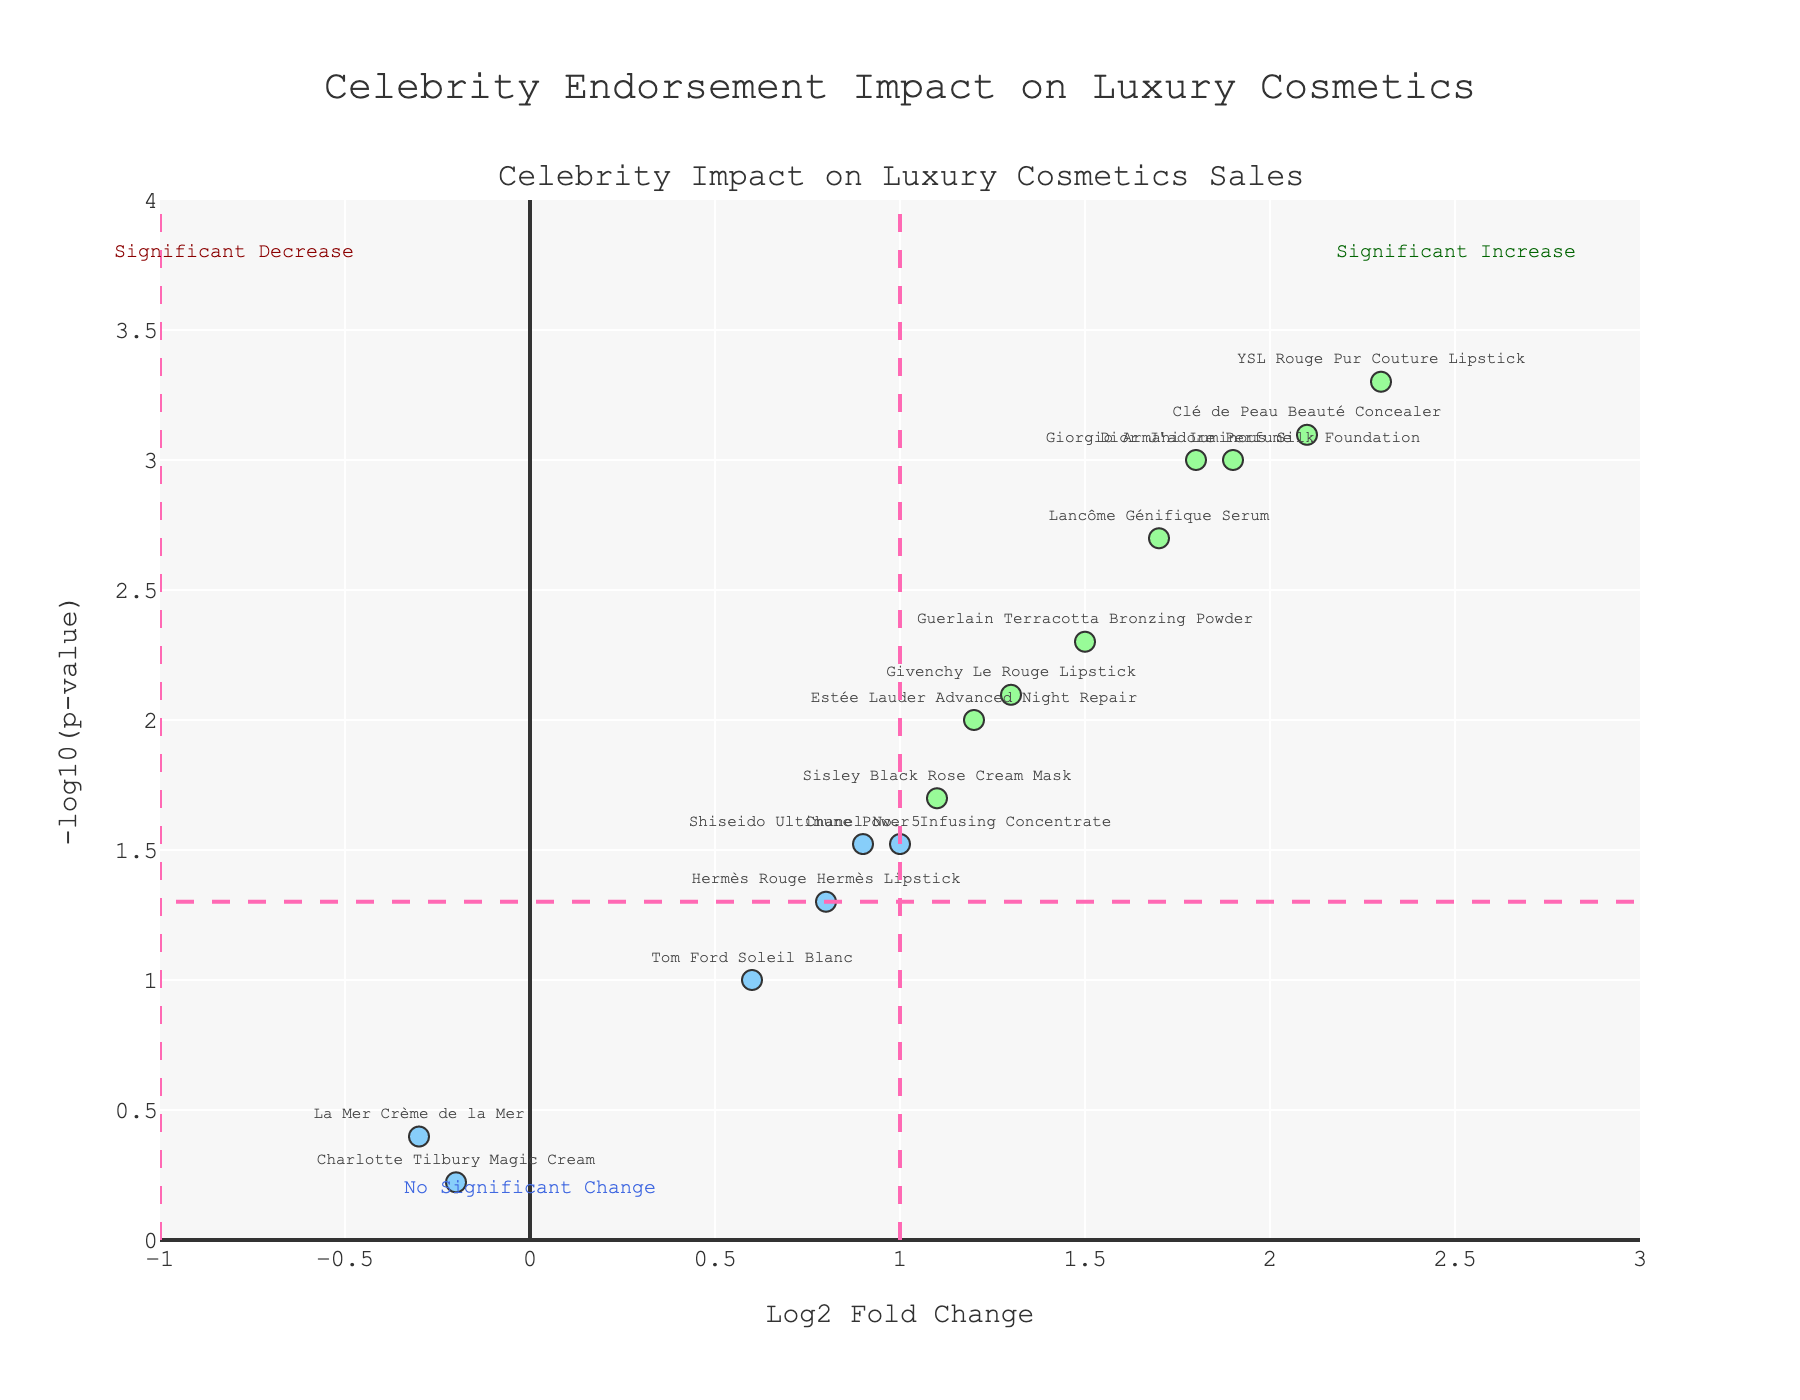What is the title of the plot? The title is displayed at the top center of the plot which reads "Celebrity Endorsement Impact on Luxury Cosmetics".
Answer: Celebrity Endorsement Impact on Luxury Cosmetics How many products show a significant increase in sales? The significant increase in sales can be identified by points above the p-value threshold (horizontal dashed line) and to the right of the log2 fold change threshold (vertical dashed pink line at x=1). Count the points above these thresholds in the plot.
Answer: Eight Which product experienced the highest log2 fold change after celebrity endorsement? By looking at the x-axis for the farthest point to the right, which indicates the highest log2 fold change (sales increase), we identify the product.
Answer: YSL Rouge Pur Couture Lipstick What color represents products with significant changes? Observe the colors of the points that are either above the p-value threshold and or to the left/right of the log2 fold change thresholds. These points are in green or orange color.
Answer: Green and Orange What is the range of the x-axis in the plot? The range can be seen on the plot's x-axis labels, which are from the minimum value to the maximum value displayed.
Answer: -1 to 3 How many products did not show a significant change in sales? Identify points within the boundaries set by the threshold lines (-1 < x < 1 and above the horizontal dashed line at y=-log10(0.05)), reflect no significant change. Count these points.
Answer: Five Which product shows the greatest decrease in sales post-endorsement? Check the leftmost point on the x-axis, which indicates the highest negative log2 fold change.
Answer: La Mer Crème de la Mer Among Dior J'adore Perfume, Estée Lauder Advanced Night Repair, and La Mer Crème de la Mer, which product had the lowest p-value? Compare the vertical positions of these three data points on the plot; the one highest on the y-axis will have the lowest p-value.
Answer: Dior J'adore Perfume How is the p-value represented in the plot? The p-value is transformed with a log10 scale and shown on the y-axis of the plot, where higher positions indicate lower p-values. The y-axis label is -log10(p-value).
Answer: -log10(p-value) 